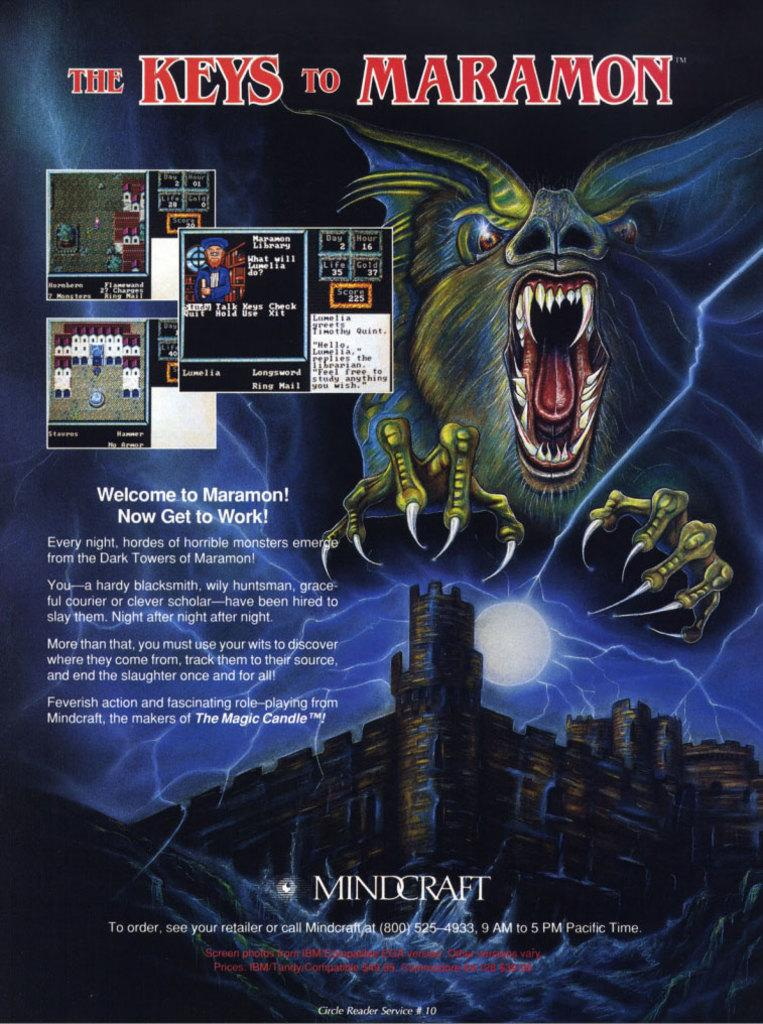<image>
Present a compact description of the photo's key features. A book by MINDCRAFT titled The Keys to Maramon. 